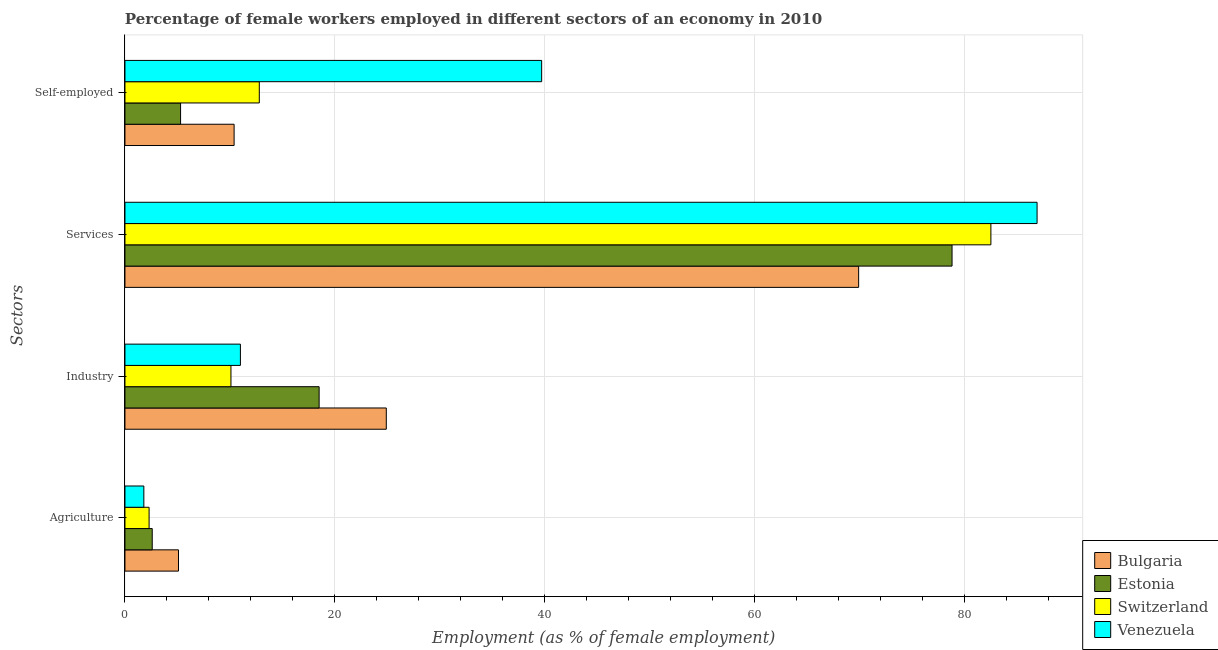How many different coloured bars are there?
Give a very brief answer. 4. How many bars are there on the 1st tick from the top?
Ensure brevity in your answer.  4. How many bars are there on the 1st tick from the bottom?
Provide a succinct answer. 4. What is the label of the 4th group of bars from the top?
Keep it short and to the point. Agriculture. What is the percentage of female workers in agriculture in Switzerland?
Provide a succinct answer. 2.3. Across all countries, what is the maximum percentage of female workers in industry?
Your answer should be very brief. 24.9. Across all countries, what is the minimum percentage of female workers in industry?
Your response must be concise. 10.1. In which country was the percentage of female workers in agriculture minimum?
Provide a short and direct response. Venezuela. What is the total percentage of female workers in services in the graph?
Provide a succinct answer. 318.1. What is the difference between the percentage of female workers in industry in Estonia and that in Switzerland?
Offer a terse response. 8.4. What is the difference between the percentage of female workers in services in Bulgaria and the percentage of self employed female workers in Switzerland?
Your response must be concise. 57.1. What is the average percentage of female workers in agriculture per country?
Ensure brevity in your answer.  2.95. What is the difference between the percentage of female workers in services and percentage of self employed female workers in Bulgaria?
Ensure brevity in your answer.  59.5. What is the ratio of the percentage of female workers in agriculture in Venezuela to that in Switzerland?
Your answer should be compact. 0.78. Is the percentage of female workers in agriculture in Venezuela less than that in Switzerland?
Give a very brief answer. Yes. Is the difference between the percentage of female workers in industry in Bulgaria and Switzerland greater than the difference between the percentage of female workers in agriculture in Bulgaria and Switzerland?
Provide a short and direct response. Yes. What is the difference between the highest and the second highest percentage of female workers in industry?
Provide a succinct answer. 6.4. What is the difference between the highest and the lowest percentage of female workers in industry?
Offer a very short reply. 14.8. Is the sum of the percentage of self employed female workers in Switzerland and Estonia greater than the maximum percentage of female workers in services across all countries?
Offer a terse response. No. What does the 2nd bar from the top in Agriculture represents?
Keep it short and to the point. Switzerland. What does the 3rd bar from the bottom in Services represents?
Keep it short and to the point. Switzerland. Is it the case that in every country, the sum of the percentage of female workers in agriculture and percentage of female workers in industry is greater than the percentage of female workers in services?
Provide a succinct answer. No. Are all the bars in the graph horizontal?
Offer a very short reply. Yes. What is the difference between two consecutive major ticks on the X-axis?
Ensure brevity in your answer.  20. Are the values on the major ticks of X-axis written in scientific E-notation?
Offer a terse response. No. Where does the legend appear in the graph?
Make the answer very short. Bottom right. What is the title of the graph?
Provide a short and direct response. Percentage of female workers employed in different sectors of an economy in 2010. What is the label or title of the X-axis?
Give a very brief answer. Employment (as % of female employment). What is the label or title of the Y-axis?
Ensure brevity in your answer.  Sectors. What is the Employment (as % of female employment) of Bulgaria in Agriculture?
Your answer should be compact. 5.1. What is the Employment (as % of female employment) of Estonia in Agriculture?
Offer a terse response. 2.6. What is the Employment (as % of female employment) of Switzerland in Agriculture?
Offer a very short reply. 2.3. What is the Employment (as % of female employment) in Venezuela in Agriculture?
Your answer should be compact. 1.8. What is the Employment (as % of female employment) in Bulgaria in Industry?
Make the answer very short. 24.9. What is the Employment (as % of female employment) in Switzerland in Industry?
Offer a very short reply. 10.1. What is the Employment (as % of female employment) of Venezuela in Industry?
Offer a very short reply. 11. What is the Employment (as % of female employment) of Bulgaria in Services?
Make the answer very short. 69.9. What is the Employment (as % of female employment) of Estonia in Services?
Your response must be concise. 78.8. What is the Employment (as % of female employment) of Switzerland in Services?
Give a very brief answer. 82.5. What is the Employment (as % of female employment) of Venezuela in Services?
Give a very brief answer. 86.9. What is the Employment (as % of female employment) of Bulgaria in Self-employed?
Offer a very short reply. 10.4. What is the Employment (as % of female employment) in Estonia in Self-employed?
Offer a terse response. 5.3. What is the Employment (as % of female employment) of Switzerland in Self-employed?
Make the answer very short. 12.8. What is the Employment (as % of female employment) of Venezuela in Self-employed?
Offer a very short reply. 39.7. Across all Sectors, what is the maximum Employment (as % of female employment) of Bulgaria?
Keep it short and to the point. 69.9. Across all Sectors, what is the maximum Employment (as % of female employment) in Estonia?
Your answer should be compact. 78.8. Across all Sectors, what is the maximum Employment (as % of female employment) of Switzerland?
Your answer should be very brief. 82.5. Across all Sectors, what is the maximum Employment (as % of female employment) in Venezuela?
Your response must be concise. 86.9. Across all Sectors, what is the minimum Employment (as % of female employment) of Bulgaria?
Offer a very short reply. 5.1. Across all Sectors, what is the minimum Employment (as % of female employment) in Estonia?
Your answer should be very brief. 2.6. Across all Sectors, what is the minimum Employment (as % of female employment) in Switzerland?
Provide a short and direct response. 2.3. Across all Sectors, what is the minimum Employment (as % of female employment) in Venezuela?
Provide a short and direct response. 1.8. What is the total Employment (as % of female employment) in Bulgaria in the graph?
Provide a succinct answer. 110.3. What is the total Employment (as % of female employment) of Estonia in the graph?
Provide a succinct answer. 105.2. What is the total Employment (as % of female employment) in Switzerland in the graph?
Give a very brief answer. 107.7. What is the total Employment (as % of female employment) of Venezuela in the graph?
Make the answer very short. 139.4. What is the difference between the Employment (as % of female employment) of Bulgaria in Agriculture and that in Industry?
Offer a terse response. -19.8. What is the difference between the Employment (as % of female employment) in Estonia in Agriculture and that in Industry?
Provide a short and direct response. -15.9. What is the difference between the Employment (as % of female employment) of Bulgaria in Agriculture and that in Services?
Provide a succinct answer. -64.8. What is the difference between the Employment (as % of female employment) in Estonia in Agriculture and that in Services?
Offer a terse response. -76.2. What is the difference between the Employment (as % of female employment) of Switzerland in Agriculture and that in Services?
Your answer should be very brief. -80.2. What is the difference between the Employment (as % of female employment) in Venezuela in Agriculture and that in Services?
Give a very brief answer. -85.1. What is the difference between the Employment (as % of female employment) of Switzerland in Agriculture and that in Self-employed?
Provide a succinct answer. -10.5. What is the difference between the Employment (as % of female employment) of Venezuela in Agriculture and that in Self-employed?
Your answer should be compact. -37.9. What is the difference between the Employment (as % of female employment) in Bulgaria in Industry and that in Services?
Your answer should be compact. -45. What is the difference between the Employment (as % of female employment) of Estonia in Industry and that in Services?
Give a very brief answer. -60.3. What is the difference between the Employment (as % of female employment) in Switzerland in Industry and that in Services?
Your response must be concise. -72.4. What is the difference between the Employment (as % of female employment) of Venezuela in Industry and that in Services?
Keep it short and to the point. -75.9. What is the difference between the Employment (as % of female employment) of Estonia in Industry and that in Self-employed?
Keep it short and to the point. 13.2. What is the difference between the Employment (as % of female employment) of Switzerland in Industry and that in Self-employed?
Offer a terse response. -2.7. What is the difference between the Employment (as % of female employment) in Venezuela in Industry and that in Self-employed?
Offer a terse response. -28.7. What is the difference between the Employment (as % of female employment) of Bulgaria in Services and that in Self-employed?
Give a very brief answer. 59.5. What is the difference between the Employment (as % of female employment) in Estonia in Services and that in Self-employed?
Your answer should be very brief. 73.5. What is the difference between the Employment (as % of female employment) of Switzerland in Services and that in Self-employed?
Ensure brevity in your answer.  69.7. What is the difference between the Employment (as % of female employment) of Venezuela in Services and that in Self-employed?
Your answer should be very brief. 47.2. What is the difference between the Employment (as % of female employment) in Bulgaria in Agriculture and the Employment (as % of female employment) in Estonia in Industry?
Your response must be concise. -13.4. What is the difference between the Employment (as % of female employment) of Bulgaria in Agriculture and the Employment (as % of female employment) of Venezuela in Industry?
Provide a short and direct response. -5.9. What is the difference between the Employment (as % of female employment) in Estonia in Agriculture and the Employment (as % of female employment) in Switzerland in Industry?
Your response must be concise. -7.5. What is the difference between the Employment (as % of female employment) of Estonia in Agriculture and the Employment (as % of female employment) of Venezuela in Industry?
Your response must be concise. -8.4. What is the difference between the Employment (as % of female employment) of Bulgaria in Agriculture and the Employment (as % of female employment) of Estonia in Services?
Offer a terse response. -73.7. What is the difference between the Employment (as % of female employment) in Bulgaria in Agriculture and the Employment (as % of female employment) in Switzerland in Services?
Make the answer very short. -77.4. What is the difference between the Employment (as % of female employment) in Bulgaria in Agriculture and the Employment (as % of female employment) in Venezuela in Services?
Your answer should be compact. -81.8. What is the difference between the Employment (as % of female employment) in Estonia in Agriculture and the Employment (as % of female employment) in Switzerland in Services?
Your response must be concise. -79.9. What is the difference between the Employment (as % of female employment) of Estonia in Agriculture and the Employment (as % of female employment) of Venezuela in Services?
Your response must be concise. -84.3. What is the difference between the Employment (as % of female employment) in Switzerland in Agriculture and the Employment (as % of female employment) in Venezuela in Services?
Offer a very short reply. -84.6. What is the difference between the Employment (as % of female employment) in Bulgaria in Agriculture and the Employment (as % of female employment) in Estonia in Self-employed?
Keep it short and to the point. -0.2. What is the difference between the Employment (as % of female employment) of Bulgaria in Agriculture and the Employment (as % of female employment) of Switzerland in Self-employed?
Your answer should be very brief. -7.7. What is the difference between the Employment (as % of female employment) of Bulgaria in Agriculture and the Employment (as % of female employment) of Venezuela in Self-employed?
Your answer should be very brief. -34.6. What is the difference between the Employment (as % of female employment) in Estonia in Agriculture and the Employment (as % of female employment) in Switzerland in Self-employed?
Offer a terse response. -10.2. What is the difference between the Employment (as % of female employment) in Estonia in Agriculture and the Employment (as % of female employment) in Venezuela in Self-employed?
Keep it short and to the point. -37.1. What is the difference between the Employment (as % of female employment) of Switzerland in Agriculture and the Employment (as % of female employment) of Venezuela in Self-employed?
Ensure brevity in your answer.  -37.4. What is the difference between the Employment (as % of female employment) of Bulgaria in Industry and the Employment (as % of female employment) of Estonia in Services?
Ensure brevity in your answer.  -53.9. What is the difference between the Employment (as % of female employment) in Bulgaria in Industry and the Employment (as % of female employment) in Switzerland in Services?
Make the answer very short. -57.6. What is the difference between the Employment (as % of female employment) of Bulgaria in Industry and the Employment (as % of female employment) of Venezuela in Services?
Ensure brevity in your answer.  -62. What is the difference between the Employment (as % of female employment) of Estonia in Industry and the Employment (as % of female employment) of Switzerland in Services?
Your response must be concise. -64. What is the difference between the Employment (as % of female employment) of Estonia in Industry and the Employment (as % of female employment) of Venezuela in Services?
Keep it short and to the point. -68.4. What is the difference between the Employment (as % of female employment) of Switzerland in Industry and the Employment (as % of female employment) of Venezuela in Services?
Give a very brief answer. -76.8. What is the difference between the Employment (as % of female employment) of Bulgaria in Industry and the Employment (as % of female employment) of Estonia in Self-employed?
Provide a succinct answer. 19.6. What is the difference between the Employment (as % of female employment) in Bulgaria in Industry and the Employment (as % of female employment) in Venezuela in Self-employed?
Provide a succinct answer. -14.8. What is the difference between the Employment (as % of female employment) of Estonia in Industry and the Employment (as % of female employment) of Switzerland in Self-employed?
Provide a succinct answer. 5.7. What is the difference between the Employment (as % of female employment) in Estonia in Industry and the Employment (as % of female employment) in Venezuela in Self-employed?
Give a very brief answer. -21.2. What is the difference between the Employment (as % of female employment) in Switzerland in Industry and the Employment (as % of female employment) in Venezuela in Self-employed?
Your answer should be compact. -29.6. What is the difference between the Employment (as % of female employment) of Bulgaria in Services and the Employment (as % of female employment) of Estonia in Self-employed?
Your answer should be very brief. 64.6. What is the difference between the Employment (as % of female employment) of Bulgaria in Services and the Employment (as % of female employment) of Switzerland in Self-employed?
Give a very brief answer. 57.1. What is the difference between the Employment (as % of female employment) in Bulgaria in Services and the Employment (as % of female employment) in Venezuela in Self-employed?
Offer a terse response. 30.2. What is the difference between the Employment (as % of female employment) of Estonia in Services and the Employment (as % of female employment) of Venezuela in Self-employed?
Your answer should be very brief. 39.1. What is the difference between the Employment (as % of female employment) in Switzerland in Services and the Employment (as % of female employment) in Venezuela in Self-employed?
Provide a succinct answer. 42.8. What is the average Employment (as % of female employment) of Bulgaria per Sectors?
Keep it short and to the point. 27.57. What is the average Employment (as % of female employment) in Estonia per Sectors?
Provide a succinct answer. 26.3. What is the average Employment (as % of female employment) of Switzerland per Sectors?
Give a very brief answer. 26.93. What is the average Employment (as % of female employment) in Venezuela per Sectors?
Keep it short and to the point. 34.85. What is the difference between the Employment (as % of female employment) of Bulgaria and Employment (as % of female employment) of Estonia in Agriculture?
Offer a terse response. 2.5. What is the difference between the Employment (as % of female employment) of Bulgaria and Employment (as % of female employment) of Switzerland in Agriculture?
Keep it short and to the point. 2.8. What is the difference between the Employment (as % of female employment) in Estonia and Employment (as % of female employment) in Venezuela in Agriculture?
Your answer should be compact. 0.8. What is the difference between the Employment (as % of female employment) in Switzerland and Employment (as % of female employment) in Venezuela in Agriculture?
Your answer should be compact. 0.5. What is the difference between the Employment (as % of female employment) in Bulgaria and Employment (as % of female employment) in Estonia in Industry?
Offer a very short reply. 6.4. What is the difference between the Employment (as % of female employment) in Bulgaria and Employment (as % of female employment) in Switzerland in Services?
Provide a short and direct response. -12.6. What is the difference between the Employment (as % of female employment) of Bulgaria and Employment (as % of female employment) of Venezuela in Services?
Keep it short and to the point. -17. What is the difference between the Employment (as % of female employment) in Estonia and Employment (as % of female employment) in Switzerland in Services?
Offer a very short reply. -3.7. What is the difference between the Employment (as % of female employment) in Bulgaria and Employment (as % of female employment) in Switzerland in Self-employed?
Your answer should be compact. -2.4. What is the difference between the Employment (as % of female employment) in Bulgaria and Employment (as % of female employment) in Venezuela in Self-employed?
Keep it short and to the point. -29.3. What is the difference between the Employment (as % of female employment) in Estonia and Employment (as % of female employment) in Venezuela in Self-employed?
Your response must be concise. -34.4. What is the difference between the Employment (as % of female employment) in Switzerland and Employment (as % of female employment) in Venezuela in Self-employed?
Your answer should be compact. -26.9. What is the ratio of the Employment (as % of female employment) in Bulgaria in Agriculture to that in Industry?
Your response must be concise. 0.2. What is the ratio of the Employment (as % of female employment) of Estonia in Agriculture to that in Industry?
Your answer should be very brief. 0.14. What is the ratio of the Employment (as % of female employment) of Switzerland in Agriculture to that in Industry?
Ensure brevity in your answer.  0.23. What is the ratio of the Employment (as % of female employment) of Venezuela in Agriculture to that in Industry?
Keep it short and to the point. 0.16. What is the ratio of the Employment (as % of female employment) in Bulgaria in Agriculture to that in Services?
Offer a terse response. 0.07. What is the ratio of the Employment (as % of female employment) of Estonia in Agriculture to that in Services?
Provide a succinct answer. 0.03. What is the ratio of the Employment (as % of female employment) of Switzerland in Agriculture to that in Services?
Provide a succinct answer. 0.03. What is the ratio of the Employment (as % of female employment) of Venezuela in Agriculture to that in Services?
Provide a succinct answer. 0.02. What is the ratio of the Employment (as % of female employment) of Bulgaria in Agriculture to that in Self-employed?
Provide a succinct answer. 0.49. What is the ratio of the Employment (as % of female employment) of Estonia in Agriculture to that in Self-employed?
Provide a succinct answer. 0.49. What is the ratio of the Employment (as % of female employment) of Switzerland in Agriculture to that in Self-employed?
Offer a terse response. 0.18. What is the ratio of the Employment (as % of female employment) in Venezuela in Agriculture to that in Self-employed?
Provide a short and direct response. 0.05. What is the ratio of the Employment (as % of female employment) of Bulgaria in Industry to that in Services?
Make the answer very short. 0.36. What is the ratio of the Employment (as % of female employment) of Estonia in Industry to that in Services?
Keep it short and to the point. 0.23. What is the ratio of the Employment (as % of female employment) in Switzerland in Industry to that in Services?
Provide a short and direct response. 0.12. What is the ratio of the Employment (as % of female employment) in Venezuela in Industry to that in Services?
Ensure brevity in your answer.  0.13. What is the ratio of the Employment (as % of female employment) of Bulgaria in Industry to that in Self-employed?
Provide a succinct answer. 2.39. What is the ratio of the Employment (as % of female employment) in Estonia in Industry to that in Self-employed?
Provide a succinct answer. 3.49. What is the ratio of the Employment (as % of female employment) in Switzerland in Industry to that in Self-employed?
Ensure brevity in your answer.  0.79. What is the ratio of the Employment (as % of female employment) in Venezuela in Industry to that in Self-employed?
Offer a terse response. 0.28. What is the ratio of the Employment (as % of female employment) of Bulgaria in Services to that in Self-employed?
Offer a terse response. 6.72. What is the ratio of the Employment (as % of female employment) in Estonia in Services to that in Self-employed?
Give a very brief answer. 14.87. What is the ratio of the Employment (as % of female employment) of Switzerland in Services to that in Self-employed?
Your response must be concise. 6.45. What is the ratio of the Employment (as % of female employment) of Venezuela in Services to that in Self-employed?
Make the answer very short. 2.19. What is the difference between the highest and the second highest Employment (as % of female employment) of Estonia?
Give a very brief answer. 60.3. What is the difference between the highest and the second highest Employment (as % of female employment) of Switzerland?
Keep it short and to the point. 69.7. What is the difference between the highest and the second highest Employment (as % of female employment) in Venezuela?
Ensure brevity in your answer.  47.2. What is the difference between the highest and the lowest Employment (as % of female employment) in Bulgaria?
Offer a terse response. 64.8. What is the difference between the highest and the lowest Employment (as % of female employment) of Estonia?
Your answer should be very brief. 76.2. What is the difference between the highest and the lowest Employment (as % of female employment) in Switzerland?
Your answer should be compact. 80.2. What is the difference between the highest and the lowest Employment (as % of female employment) in Venezuela?
Ensure brevity in your answer.  85.1. 